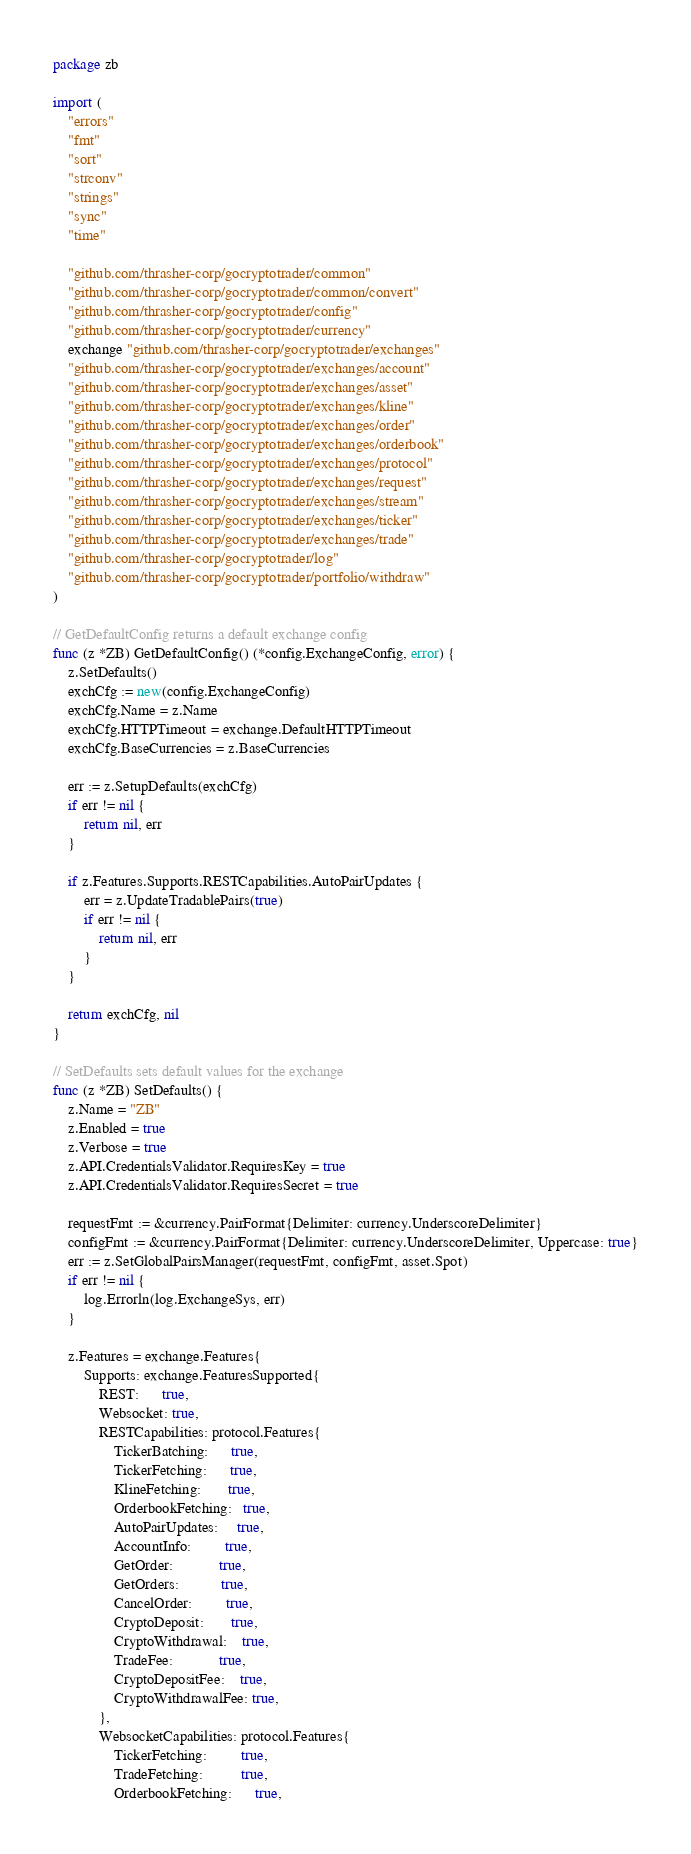Convert code to text. <code><loc_0><loc_0><loc_500><loc_500><_Go_>package zb

import (
	"errors"
	"fmt"
	"sort"
	"strconv"
	"strings"
	"sync"
	"time"

	"github.com/thrasher-corp/gocryptotrader/common"
	"github.com/thrasher-corp/gocryptotrader/common/convert"
	"github.com/thrasher-corp/gocryptotrader/config"
	"github.com/thrasher-corp/gocryptotrader/currency"
	exchange "github.com/thrasher-corp/gocryptotrader/exchanges"
	"github.com/thrasher-corp/gocryptotrader/exchanges/account"
	"github.com/thrasher-corp/gocryptotrader/exchanges/asset"
	"github.com/thrasher-corp/gocryptotrader/exchanges/kline"
	"github.com/thrasher-corp/gocryptotrader/exchanges/order"
	"github.com/thrasher-corp/gocryptotrader/exchanges/orderbook"
	"github.com/thrasher-corp/gocryptotrader/exchanges/protocol"
	"github.com/thrasher-corp/gocryptotrader/exchanges/request"
	"github.com/thrasher-corp/gocryptotrader/exchanges/stream"
	"github.com/thrasher-corp/gocryptotrader/exchanges/ticker"
	"github.com/thrasher-corp/gocryptotrader/exchanges/trade"
	"github.com/thrasher-corp/gocryptotrader/log"
	"github.com/thrasher-corp/gocryptotrader/portfolio/withdraw"
)

// GetDefaultConfig returns a default exchange config
func (z *ZB) GetDefaultConfig() (*config.ExchangeConfig, error) {
	z.SetDefaults()
	exchCfg := new(config.ExchangeConfig)
	exchCfg.Name = z.Name
	exchCfg.HTTPTimeout = exchange.DefaultHTTPTimeout
	exchCfg.BaseCurrencies = z.BaseCurrencies

	err := z.SetupDefaults(exchCfg)
	if err != nil {
		return nil, err
	}

	if z.Features.Supports.RESTCapabilities.AutoPairUpdates {
		err = z.UpdateTradablePairs(true)
		if err != nil {
			return nil, err
		}
	}

	return exchCfg, nil
}

// SetDefaults sets default values for the exchange
func (z *ZB) SetDefaults() {
	z.Name = "ZB"
	z.Enabled = true
	z.Verbose = true
	z.API.CredentialsValidator.RequiresKey = true
	z.API.CredentialsValidator.RequiresSecret = true

	requestFmt := &currency.PairFormat{Delimiter: currency.UnderscoreDelimiter}
	configFmt := &currency.PairFormat{Delimiter: currency.UnderscoreDelimiter, Uppercase: true}
	err := z.SetGlobalPairsManager(requestFmt, configFmt, asset.Spot)
	if err != nil {
		log.Errorln(log.ExchangeSys, err)
	}

	z.Features = exchange.Features{
		Supports: exchange.FeaturesSupported{
			REST:      true,
			Websocket: true,
			RESTCapabilities: protocol.Features{
				TickerBatching:      true,
				TickerFetching:      true,
				KlineFetching:       true,
				OrderbookFetching:   true,
				AutoPairUpdates:     true,
				AccountInfo:         true,
				GetOrder:            true,
				GetOrders:           true,
				CancelOrder:         true,
				CryptoDeposit:       true,
				CryptoWithdrawal:    true,
				TradeFee:            true,
				CryptoDepositFee:    true,
				CryptoWithdrawalFee: true,
			},
			WebsocketCapabilities: protocol.Features{
				TickerFetching:         true,
				TradeFetching:          true,
				OrderbookFetching:      true,</code> 